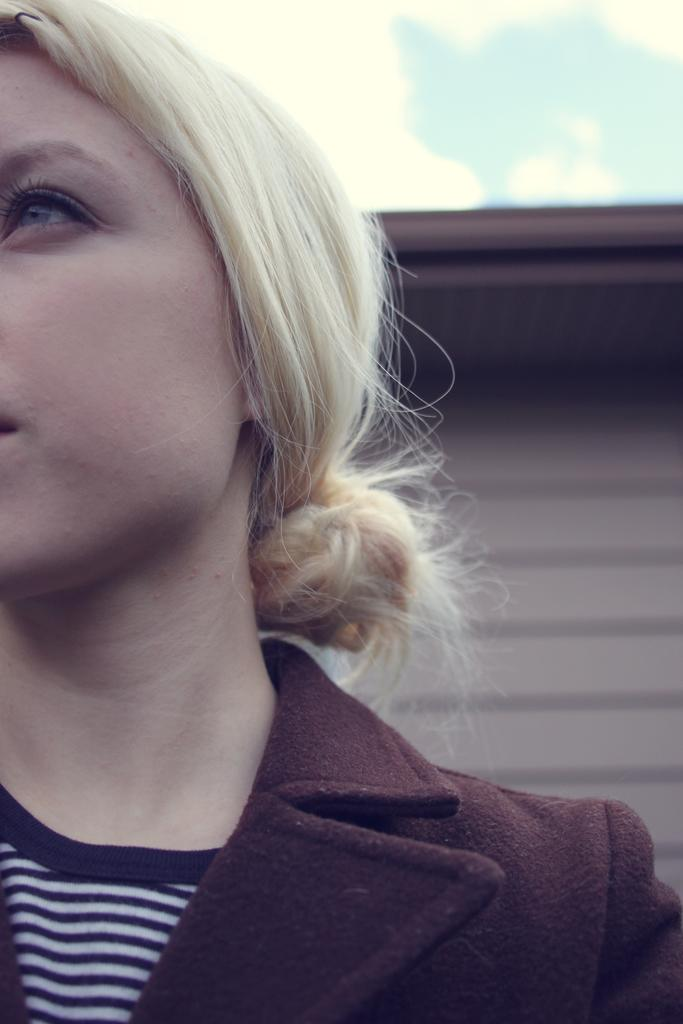Who is the main subject on the left side of the image? There is a woman on the left side of the image. What can be seen in the background of the image? There is a wall in the background of the image. What is visible in the sky in the background of the image? Clouds are visible in the sky in the background of the image. What word is the woman trying to spell with her hands in the image? There is no indication in the image that the woman is trying to spell a word with her hands, as she is not using her hands in any such manner. 